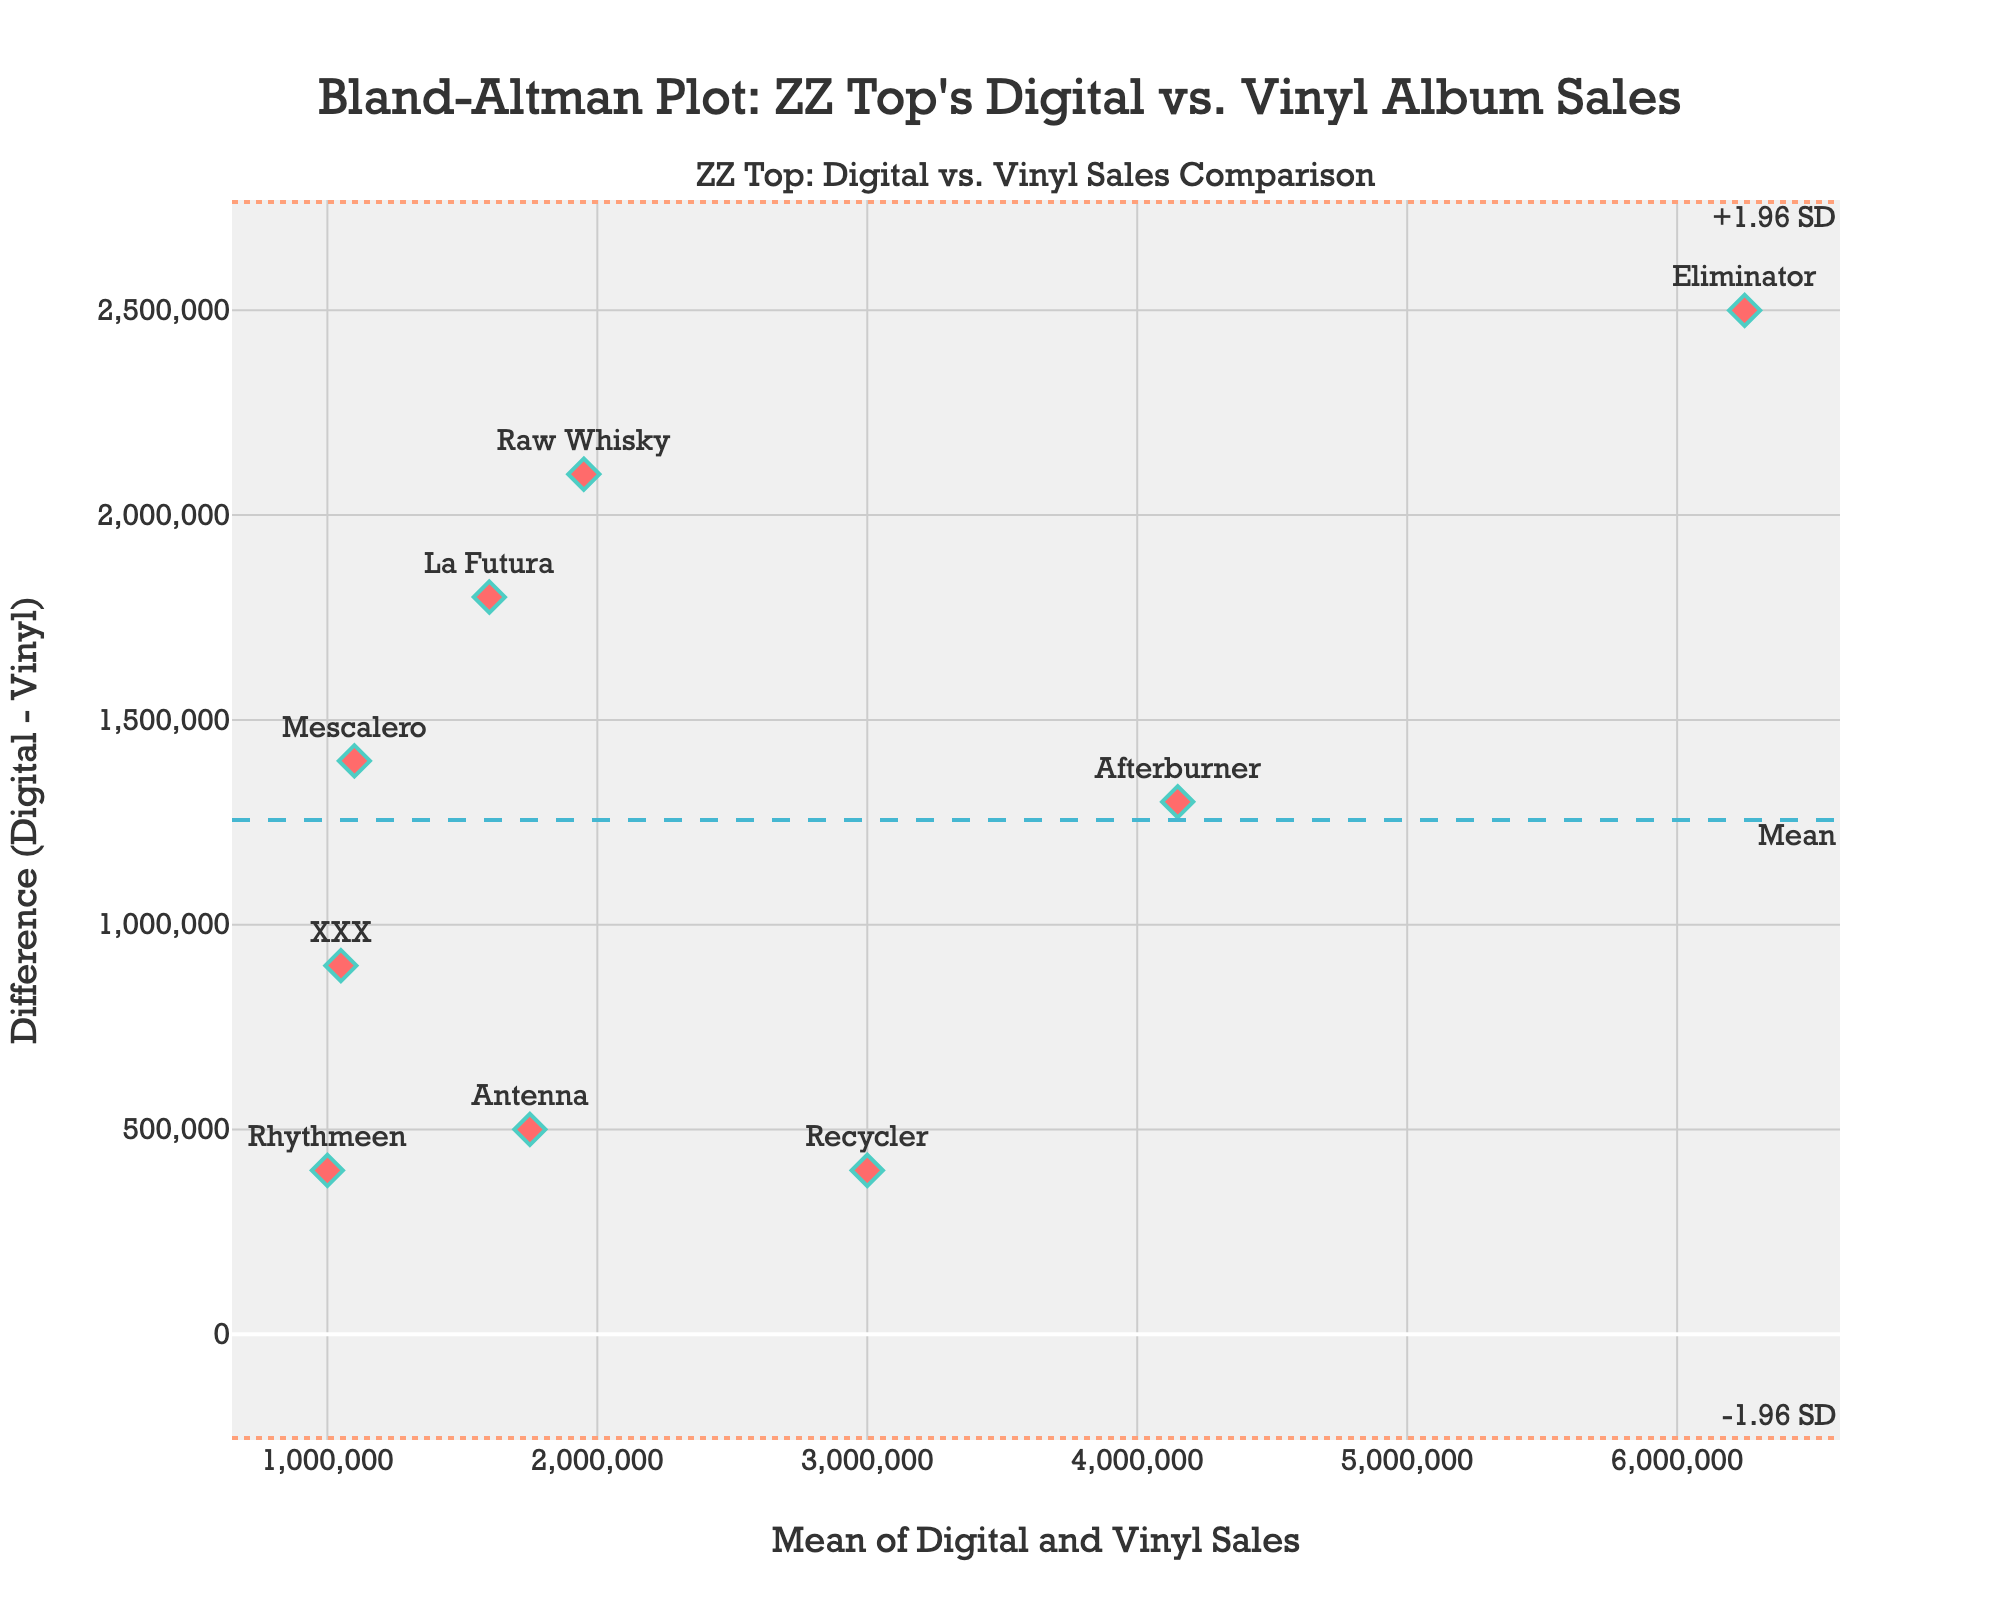what is the main title of the figure? The main title is prominently displayed at the top of the figure and provides a summary of what the plot represents.
Answer: Bland-Altman Plot: ZZ Top's Digital vs. Vinyl Album Sales how many albums are represented in the figure? Each point in the figure corresponds to one album and is labeled with its name.
Answer: 9 which album has the highest mean sales? The mean sales for each album is displayed on the x-axis, and the album labels help identify them. The album with the rightmost point has the highest mean sales.
Answer: Eliminator what is the mean difference between digital and vinyl sales? The mean difference is indicated by a dashed line on the y-axis, labeled as "Mean".
Answer: 1111111 which album shows the greatest difference between digital and vinyl sales? The difference is represented on the y-axis. The highest (positive) y-value corresponds to the greatest difference.
Answer: Raw Whisky which albums have a difference in sales within ±1.96 standard deviations from the mean difference? Points falling between the dotted lines labeled "+1.96 SD" and "-1.96 SD" represent albums within these limits on the y-axis.
Answer: Antenna, Recycler, Afterburner, Eliminator, and Rhythmeen is there an album with more vinyl sales than digital sales? Look for any point below the x-axis where the digital sales (y-value) would be negative.
Answer: No what is the approximate range of mean sales for all albums? The x-axis details the mean sales, so identifying the lowest and highest x-values will give the range.
Answer: 1,000,000 to 6,250,000 how many albums have mean sales less than 2,000,000 but a difference greater than 1,000,000? Look for points on the left side of the x-axis (less than 2,000,000) that are above the 1,000,000 mark on the y-axis.
Answer: 3 (XXX, Mescalero, La Futura) is there any visible trend between mean sales and the difference in sales? Assess if there is a pattern in how points are scattered with respect to the x-axis (mean) and y-axis (difference).
Answer: No clear trend 